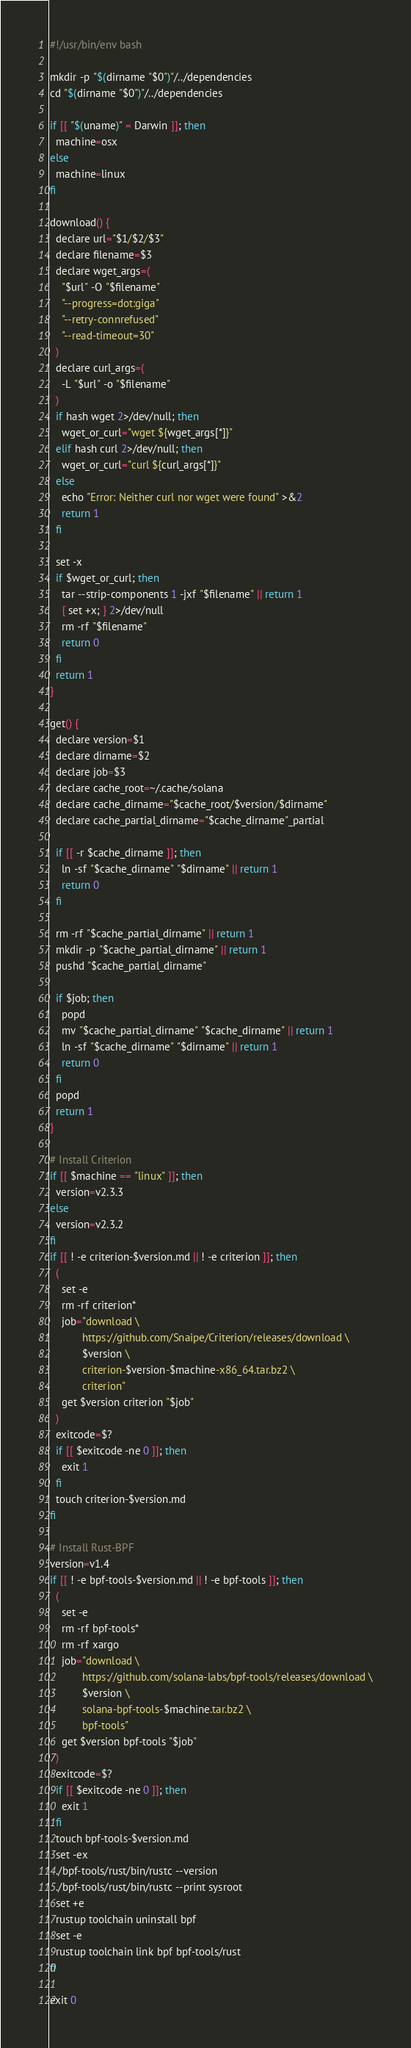Convert code to text. <code><loc_0><loc_0><loc_500><loc_500><_Bash_>#!/usr/bin/env bash

mkdir -p "$(dirname "$0")"/../dependencies
cd "$(dirname "$0")"/../dependencies

if [[ "$(uname)" = Darwin ]]; then
  machine=osx
else
  machine=linux
fi

download() {
  declare url="$1/$2/$3"
  declare filename=$3
  declare wget_args=(
    "$url" -O "$filename"
    "--progress=dot:giga"
    "--retry-connrefused"
    "--read-timeout=30"
  )
  declare curl_args=(
    -L "$url" -o "$filename"
  )
  if hash wget 2>/dev/null; then
    wget_or_curl="wget ${wget_args[*]}"
  elif hash curl 2>/dev/null; then
    wget_or_curl="curl ${curl_args[*]}"
  else
    echo "Error: Neither curl nor wget were found" >&2
    return 1
  fi

  set -x
  if $wget_or_curl; then
    tar --strip-components 1 -jxf "$filename" || return 1
    { set +x; } 2>/dev/null
    rm -rf "$filename"
    return 0
  fi
  return 1
}

get() {
  declare version=$1
  declare dirname=$2
  declare job=$3
  declare cache_root=~/.cache/solana
  declare cache_dirname="$cache_root/$version/$dirname"
  declare cache_partial_dirname="$cache_dirname"_partial

  if [[ -r $cache_dirname ]]; then
    ln -sf "$cache_dirname" "$dirname" || return 1
    return 0
  fi

  rm -rf "$cache_partial_dirname" || return 1
  mkdir -p "$cache_partial_dirname" || return 1
  pushd "$cache_partial_dirname"

  if $job; then
    popd
    mv "$cache_partial_dirname" "$cache_dirname" || return 1
    ln -sf "$cache_dirname" "$dirname" || return 1
    return 0
  fi
  popd
  return 1
}

# Install Criterion
if [[ $machine == "linux" ]]; then
  version=v2.3.3
else
  version=v2.3.2
fi
if [[ ! -e criterion-$version.md || ! -e criterion ]]; then
  (
    set -e
    rm -rf criterion*
    job="download \
           https://github.com/Snaipe/Criterion/releases/download \
           $version \
           criterion-$version-$machine-x86_64.tar.bz2 \
           criterion"
    get $version criterion "$job"
  )
  exitcode=$?
  if [[ $exitcode -ne 0 ]]; then
    exit 1
  fi
  touch criterion-$version.md
fi

# Install Rust-BPF
version=v1.4
if [[ ! -e bpf-tools-$version.md || ! -e bpf-tools ]]; then
  (
    set -e
    rm -rf bpf-tools*
    rm -rf xargo
    job="download \
           https://github.com/solana-labs/bpf-tools/releases/download \
           $version \
           solana-bpf-tools-$machine.tar.bz2 \
           bpf-tools"
    get $version bpf-tools "$job"
  )
  exitcode=$?
  if [[ $exitcode -ne 0 ]]; then
    exit 1
  fi
  touch bpf-tools-$version.md
  set -ex
  ./bpf-tools/rust/bin/rustc --version
  ./bpf-tools/rust/bin/rustc --print sysroot
  set +e
  rustup toolchain uninstall bpf
  set -e
  rustup toolchain link bpf bpf-tools/rust
fi

exit 0
</code> 